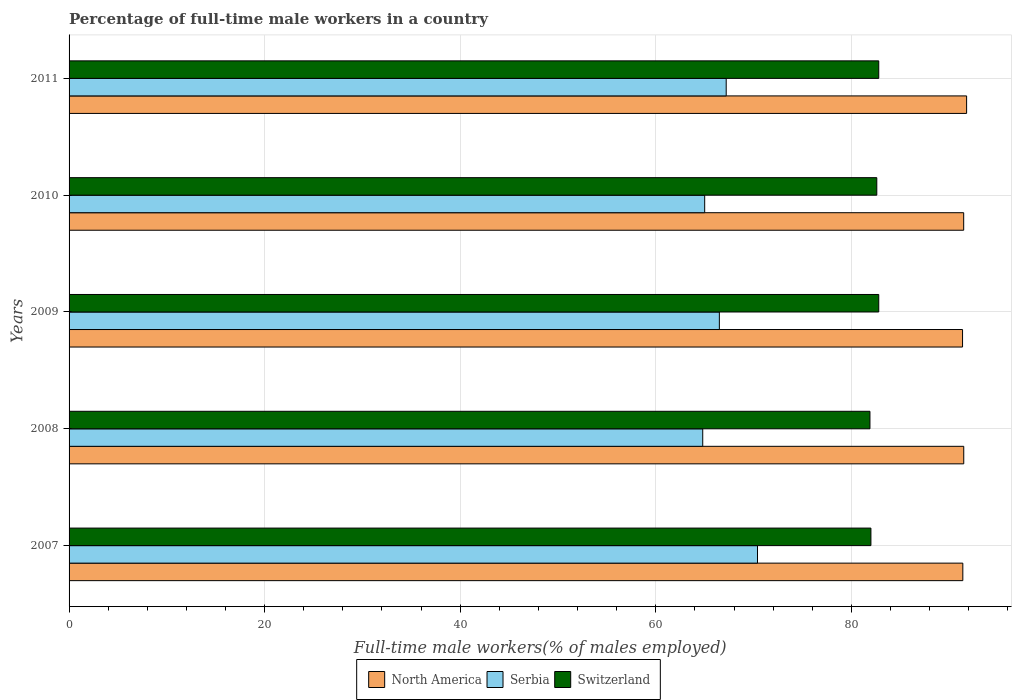Are the number of bars per tick equal to the number of legend labels?
Give a very brief answer. Yes. How many bars are there on the 4th tick from the top?
Provide a succinct answer. 3. How many bars are there on the 5th tick from the bottom?
Offer a terse response. 3. What is the label of the 1st group of bars from the top?
Provide a short and direct response. 2011. In how many cases, is the number of bars for a given year not equal to the number of legend labels?
Provide a short and direct response. 0. What is the percentage of full-time male workers in Serbia in 2008?
Offer a very short reply. 64.8. Across all years, what is the maximum percentage of full-time male workers in Switzerland?
Keep it short and to the point. 82.8. Across all years, what is the minimum percentage of full-time male workers in Serbia?
Keep it short and to the point. 64.8. In which year was the percentage of full-time male workers in Serbia maximum?
Your answer should be very brief. 2007. What is the total percentage of full-time male workers in North America in the graph?
Your answer should be compact. 457.53. What is the difference between the percentage of full-time male workers in North America in 2009 and that in 2011?
Offer a very short reply. -0.42. What is the difference between the percentage of full-time male workers in North America in 2011 and the percentage of full-time male workers in Switzerland in 2008?
Ensure brevity in your answer.  9.89. What is the average percentage of full-time male workers in North America per year?
Ensure brevity in your answer.  91.51. In the year 2008, what is the difference between the percentage of full-time male workers in Serbia and percentage of full-time male workers in Switzerland?
Ensure brevity in your answer.  -17.1. What is the ratio of the percentage of full-time male workers in North America in 2007 to that in 2009?
Offer a terse response. 1. Is the percentage of full-time male workers in North America in 2009 less than that in 2011?
Make the answer very short. Yes. Is the difference between the percentage of full-time male workers in Serbia in 2007 and 2008 greater than the difference between the percentage of full-time male workers in Switzerland in 2007 and 2008?
Give a very brief answer. Yes. What is the difference between the highest and the second highest percentage of full-time male workers in Switzerland?
Provide a succinct answer. 0. What is the difference between the highest and the lowest percentage of full-time male workers in Serbia?
Offer a terse response. 5.6. What does the 2nd bar from the top in 2010 represents?
Offer a very short reply. Serbia. What does the 3rd bar from the bottom in 2007 represents?
Provide a short and direct response. Switzerland. Is it the case that in every year, the sum of the percentage of full-time male workers in Serbia and percentage of full-time male workers in North America is greater than the percentage of full-time male workers in Switzerland?
Provide a succinct answer. Yes. What is the difference between two consecutive major ticks on the X-axis?
Ensure brevity in your answer.  20. Where does the legend appear in the graph?
Ensure brevity in your answer.  Bottom center. What is the title of the graph?
Your response must be concise. Percentage of full-time male workers in a country. What is the label or title of the X-axis?
Offer a very short reply. Full-time male workers(% of males employed). What is the Full-time male workers(% of males employed) of North America in 2007?
Offer a terse response. 91.4. What is the Full-time male workers(% of males employed) of Serbia in 2007?
Ensure brevity in your answer.  70.4. What is the Full-time male workers(% of males employed) of Switzerland in 2007?
Offer a very short reply. 82. What is the Full-time male workers(% of males employed) of North America in 2008?
Provide a succinct answer. 91.49. What is the Full-time male workers(% of males employed) in Serbia in 2008?
Give a very brief answer. 64.8. What is the Full-time male workers(% of males employed) in Switzerland in 2008?
Provide a succinct answer. 81.9. What is the Full-time male workers(% of males employed) of North America in 2009?
Offer a very short reply. 91.37. What is the Full-time male workers(% of males employed) of Serbia in 2009?
Give a very brief answer. 66.5. What is the Full-time male workers(% of males employed) of Switzerland in 2009?
Provide a succinct answer. 82.8. What is the Full-time male workers(% of males employed) of North America in 2010?
Offer a very short reply. 91.49. What is the Full-time male workers(% of males employed) of Switzerland in 2010?
Offer a very short reply. 82.6. What is the Full-time male workers(% of males employed) of North America in 2011?
Ensure brevity in your answer.  91.79. What is the Full-time male workers(% of males employed) in Serbia in 2011?
Give a very brief answer. 67.2. What is the Full-time male workers(% of males employed) in Switzerland in 2011?
Offer a terse response. 82.8. Across all years, what is the maximum Full-time male workers(% of males employed) of North America?
Make the answer very short. 91.79. Across all years, what is the maximum Full-time male workers(% of males employed) of Serbia?
Provide a short and direct response. 70.4. Across all years, what is the maximum Full-time male workers(% of males employed) of Switzerland?
Offer a terse response. 82.8. Across all years, what is the minimum Full-time male workers(% of males employed) in North America?
Your answer should be very brief. 91.37. Across all years, what is the minimum Full-time male workers(% of males employed) in Serbia?
Keep it short and to the point. 64.8. Across all years, what is the minimum Full-time male workers(% of males employed) in Switzerland?
Your answer should be very brief. 81.9. What is the total Full-time male workers(% of males employed) in North America in the graph?
Offer a very short reply. 457.53. What is the total Full-time male workers(% of males employed) of Serbia in the graph?
Offer a very short reply. 333.9. What is the total Full-time male workers(% of males employed) of Switzerland in the graph?
Your answer should be very brief. 412.1. What is the difference between the Full-time male workers(% of males employed) of North America in 2007 and that in 2008?
Keep it short and to the point. -0.1. What is the difference between the Full-time male workers(% of males employed) of Serbia in 2007 and that in 2008?
Make the answer very short. 5.6. What is the difference between the Full-time male workers(% of males employed) in North America in 2007 and that in 2009?
Give a very brief answer. 0.03. What is the difference between the Full-time male workers(% of males employed) of Serbia in 2007 and that in 2009?
Provide a succinct answer. 3.9. What is the difference between the Full-time male workers(% of males employed) in Switzerland in 2007 and that in 2009?
Your response must be concise. -0.8. What is the difference between the Full-time male workers(% of males employed) in North America in 2007 and that in 2010?
Offer a terse response. -0.09. What is the difference between the Full-time male workers(% of males employed) of North America in 2007 and that in 2011?
Ensure brevity in your answer.  -0.39. What is the difference between the Full-time male workers(% of males employed) of Switzerland in 2007 and that in 2011?
Your answer should be very brief. -0.8. What is the difference between the Full-time male workers(% of males employed) in North America in 2008 and that in 2009?
Give a very brief answer. 0.12. What is the difference between the Full-time male workers(% of males employed) of Serbia in 2008 and that in 2009?
Your answer should be very brief. -1.7. What is the difference between the Full-time male workers(% of males employed) of Switzerland in 2008 and that in 2009?
Ensure brevity in your answer.  -0.9. What is the difference between the Full-time male workers(% of males employed) in North America in 2008 and that in 2010?
Keep it short and to the point. 0.01. What is the difference between the Full-time male workers(% of males employed) in Switzerland in 2008 and that in 2010?
Ensure brevity in your answer.  -0.7. What is the difference between the Full-time male workers(% of males employed) in North America in 2008 and that in 2011?
Offer a terse response. -0.29. What is the difference between the Full-time male workers(% of males employed) in Serbia in 2008 and that in 2011?
Your response must be concise. -2.4. What is the difference between the Full-time male workers(% of males employed) in North America in 2009 and that in 2010?
Offer a terse response. -0.12. What is the difference between the Full-time male workers(% of males employed) in North America in 2009 and that in 2011?
Offer a very short reply. -0.42. What is the difference between the Full-time male workers(% of males employed) of North America in 2010 and that in 2011?
Your response must be concise. -0.3. What is the difference between the Full-time male workers(% of males employed) in Serbia in 2010 and that in 2011?
Provide a short and direct response. -2.2. What is the difference between the Full-time male workers(% of males employed) in Switzerland in 2010 and that in 2011?
Your answer should be compact. -0.2. What is the difference between the Full-time male workers(% of males employed) in North America in 2007 and the Full-time male workers(% of males employed) in Serbia in 2008?
Give a very brief answer. 26.6. What is the difference between the Full-time male workers(% of males employed) of North America in 2007 and the Full-time male workers(% of males employed) of Switzerland in 2008?
Your answer should be very brief. 9.5. What is the difference between the Full-time male workers(% of males employed) in Serbia in 2007 and the Full-time male workers(% of males employed) in Switzerland in 2008?
Provide a succinct answer. -11.5. What is the difference between the Full-time male workers(% of males employed) in North America in 2007 and the Full-time male workers(% of males employed) in Serbia in 2009?
Keep it short and to the point. 24.9. What is the difference between the Full-time male workers(% of males employed) in North America in 2007 and the Full-time male workers(% of males employed) in Switzerland in 2009?
Your answer should be compact. 8.6. What is the difference between the Full-time male workers(% of males employed) of North America in 2007 and the Full-time male workers(% of males employed) of Serbia in 2010?
Your response must be concise. 26.4. What is the difference between the Full-time male workers(% of males employed) in North America in 2007 and the Full-time male workers(% of males employed) in Switzerland in 2010?
Provide a short and direct response. 8.8. What is the difference between the Full-time male workers(% of males employed) of North America in 2007 and the Full-time male workers(% of males employed) of Serbia in 2011?
Your answer should be compact. 24.2. What is the difference between the Full-time male workers(% of males employed) in North America in 2007 and the Full-time male workers(% of males employed) in Switzerland in 2011?
Your response must be concise. 8.6. What is the difference between the Full-time male workers(% of males employed) in Serbia in 2007 and the Full-time male workers(% of males employed) in Switzerland in 2011?
Provide a short and direct response. -12.4. What is the difference between the Full-time male workers(% of males employed) in North America in 2008 and the Full-time male workers(% of males employed) in Serbia in 2009?
Your response must be concise. 24.99. What is the difference between the Full-time male workers(% of males employed) of North America in 2008 and the Full-time male workers(% of males employed) of Switzerland in 2009?
Make the answer very short. 8.69. What is the difference between the Full-time male workers(% of males employed) in Serbia in 2008 and the Full-time male workers(% of males employed) in Switzerland in 2009?
Ensure brevity in your answer.  -18. What is the difference between the Full-time male workers(% of males employed) in North America in 2008 and the Full-time male workers(% of males employed) in Serbia in 2010?
Provide a succinct answer. 26.49. What is the difference between the Full-time male workers(% of males employed) in North America in 2008 and the Full-time male workers(% of males employed) in Switzerland in 2010?
Provide a short and direct response. 8.89. What is the difference between the Full-time male workers(% of males employed) of Serbia in 2008 and the Full-time male workers(% of males employed) of Switzerland in 2010?
Your response must be concise. -17.8. What is the difference between the Full-time male workers(% of males employed) in North America in 2008 and the Full-time male workers(% of males employed) in Serbia in 2011?
Give a very brief answer. 24.29. What is the difference between the Full-time male workers(% of males employed) of North America in 2008 and the Full-time male workers(% of males employed) of Switzerland in 2011?
Ensure brevity in your answer.  8.69. What is the difference between the Full-time male workers(% of males employed) in Serbia in 2008 and the Full-time male workers(% of males employed) in Switzerland in 2011?
Keep it short and to the point. -18. What is the difference between the Full-time male workers(% of males employed) of North America in 2009 and the Full-time male workers(% of males employed) of Serbia in 2010?
Your answer should be compact. 26.37. What is the difference between the Full-time male workers(% of males employed) of North America in 2009 and the Full-time male workers(% of males employed) of Switzerland in 2010?
Your response must be concise. 8.77. What is the difference between the Full-time male workers(% of males employed) of Serbia in 2009 and the Full-time male workers(% of males employed) of Switzerland in 2010?
Provide a short and direct response. -16.1. What is the difference between the Full-time male workers(% of males employed) of North America in 2009 and the Full-time male workers(% of males employed) of Serbia in 2011?
Ensure brevity in your answer.  24.17. What is the difference between the Full-time male workers(% of males employed) in North America in 2009 and the Full-time male workers(% of males employed) in Switzerland in 2011?
Make the answer very short. 8.57. What is the difference between the Full-time male workers(% of males employed) of Serbia in 2009 and the Full-time male workers(% of males employed) of Switzerland in 2011?
Keep it short and to the point. -16.3. What is the difference between the Full-time male workers(% of males employed) of North America in 2010 and the Full-time male workers(% of males employed) of Serbia in 2011?
Provide a succinct answer. 24.29. What is the difference between the Full-time male workers(% of males employed) of North America in 2010 and the Full-time male workers(% of males employed) of Switzerland in 2011?
Provide a short and direct response. 8.69. What is the difference between the Full-time male workers(% of males employed) in Serbia in 2010 and the Full-time male workers(% of males employed) in Switzerland in 2011?
Offer a terse response. -17.8. What is the average Full-time male workers(% of males employed) of North America per year?
Give a very brief answer. 91.51. What is the average Full-time male workers(% of males employed) of Serbia per year?
Your answer should be very brief. 66.78. What is the average Full-time male workers(% of males employed) of Switzerland per year?
Give a very brief answer. 82.42. In the year 2007, what is the difference between the Full-time male workers(% of males employed) in North America and Full-time male workers(% of males employed) in Serbia?
Your answer should be compact. 21. In the year 2007, what is the difference between the Full-time male workers(% of males employed) of North America and Full-time male workers(% of males employed) of Switzerland?
Provide a short and direct response. 9.4. In the year 2008, what is the difference between the Full-time male workers(% of males employed) of North America and Full-time male workers(% of males employed) of Serbia?
Give a very brief answer. 26.69. In the year 2008, what is the difference between the Full-time male workers(% of males employed) of North America and Full-time male workers(% of males employed) of Switzerland?
Offer a very short reply. 9.59. In the year 2008, what is the difference between the Full-time male workers(% of males employed) in Serbia and Full-time male workers(% of males employed) in Switzerland?
Offer a terse response. -17.1. In the year 2009, what is the difference between the Full-time male workers(% of males employed) in North America and Full-time male workers(% of males employed) in Serbia?
Provide a short and direct response. 24.87. In the year 2009, what is the difference between the Full-time male workers(% of males employed) in North America and Full-time male workers(% of males employed) in Switzerland?
Offer a terse response. 8.57. In the year 2009, what is the difference between the Full-time male workers(% of males employed) in Serbia and Full-time male workers(% of males employed) in Switzerland?
Your response must be concise. -16.3. In the year 2010, what is the difference between the Full-time male workers(% of males employed) of North America and Full-time male workers(% of males employed) of Serbia?
Offer a terse response. 26.49. In the year 2010, what is the difference between the Full-time male workers(% of males employed) in North America and Full-time male workers(% of males employed) in Switzerland?
Offer a terse response. 8.89. In the year 2010, what is the difference between the Full-time male workers(% of males employed) in Serbia and Full-time male workers(% of males employed) in Switzerland?
Offer a terse response. -17.6. In the year 2011, what is the difference between the Full-time male workers(% of males employed) of North America and Full-time male workers(% of males employed) of Serbia?
Give a very brief answer. 24.59. In the year 2011, what is the difference between the Full-time male workers(% of males employed) in North America and Full-time male workers(% of males employed) in Switzerland?
Ensure brevity in your answer.  8.99. In the year 2011, what is the difference between the Full-time male workers(% of males employed) in Serbia and Full-time male workers(% of males employed) in Switzerland?
Make the answer very short. -15.6. What is the ratio of the Full-time male workers(% of males employed) of Serbia in 2007 to that in 2008?
Provide a short and direct response. 1.09. What is the ratio of the Full-time male workers(% of males employed) of Serbia in 2007 to that in 2009?
Give a very brief answer. 1.06. What is the ratio of the Full-time male workers(% of males employed) in Switzerland in 2007 to that in 2009?
Keep it short and to the point. 0.99. What is the ratio of the Full-time male workers(% of males employed) in North America in 2007 to that in 2010?
Your response must be concise. 1. What is the ratio of the Full-time male workers(% of males employed) in Serbia in 2007 to that in 2010?
Offer a very short reply. 1.08. What is the ratio of the Full-time male workers(% of males employed) in Serbia in 2007 to that in 2011?
Ensure brevity in your answer.  1.05. What is the ratio of the Full-time male workers(% of males employed) of Switzerland in 2007 to that in 2011?
Your answer should be compact. 0.99. What is the ratio of the Full-time male workers(% of males employed) in Serbia in 2008 to that in 2009?
Offer a very short reply. 0.97. What is the ratio of the Full-time male workers(% of males employed) of Switzerland in 2008 to that in 2009?
Give a very brief answer. 0.99. What is the ratio of the Full-time male workers(% of males employed) of Serbia in 2008 to that in 2011?
Offer a very short reply. 0.96. What is the ratio of the Full-time male workers(% of males employed) in Switzerland in 2008 to that in 2011?
Your answer should be very brief. 0.99. What is the ratio of the Full-time male workers(% of males employed) in North America in 2009 to that in 2010?
Offer a terse response. 1. What is the ratio of the Full-time male workers(% of males employed) of Serbia in 2009 to that in 2010?
Make the answer very short. 1.02. What is the ratio of the Full-time male workers(% of males employed) in North America in 2009 to that in 2011?
Provide a succinct answer. 1. What is the ratio of the Full-time male workers(% of males employed) in Serbia in 2009 to that in 2011?
Give a very brief answer. 0.99. What is the ratio of the Full-time male workers(% of males employed) of Switzerland in 2009 to that in 2011?
Provide a short and direct response. 1. What is the ratio of the Full-time male workers(% of males employed) in Serbia in 2010 to that in 2011?
Make the answer very short. 0.97. What is the difference between the highest and the second highest Full-time male workers(% of males employed) of North America?
Keep it short and to the point. 0.29. What is the difference between the highest and the second highest Full-time male workers(% of males employed) of Switzerland?
Ensure brevity in your answer.  0. What is the difference between the highest and the lowest Full-time male workers(% of males employed) of North America?
Give a very brief answer. 0.42. What is the difference between the highest and the lowest Full-time male workers(% of males employed) in Switzerland?
Make the answer very short. 0.9. 